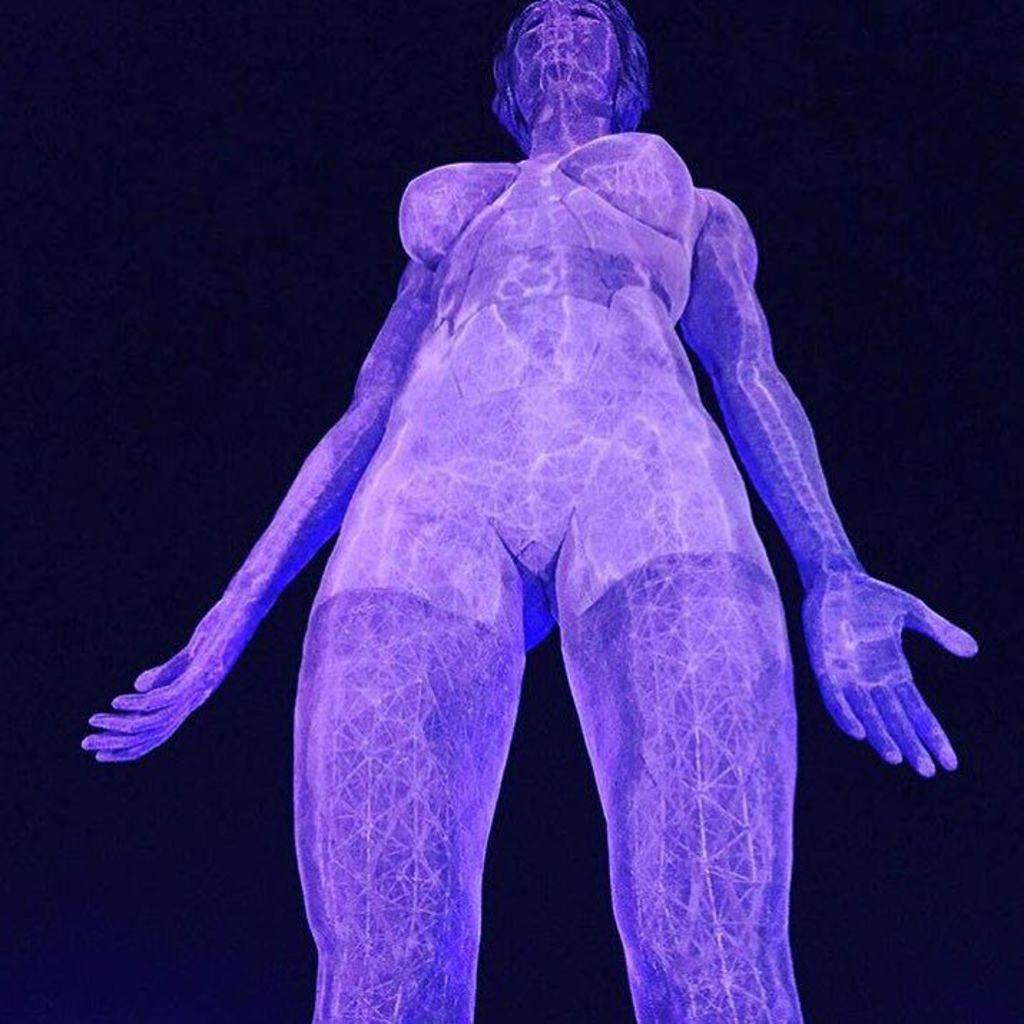In one or two sentences, can you explain what this image depicts? This is an animated picture. In the picture there is a picture of women. The background is dark. 